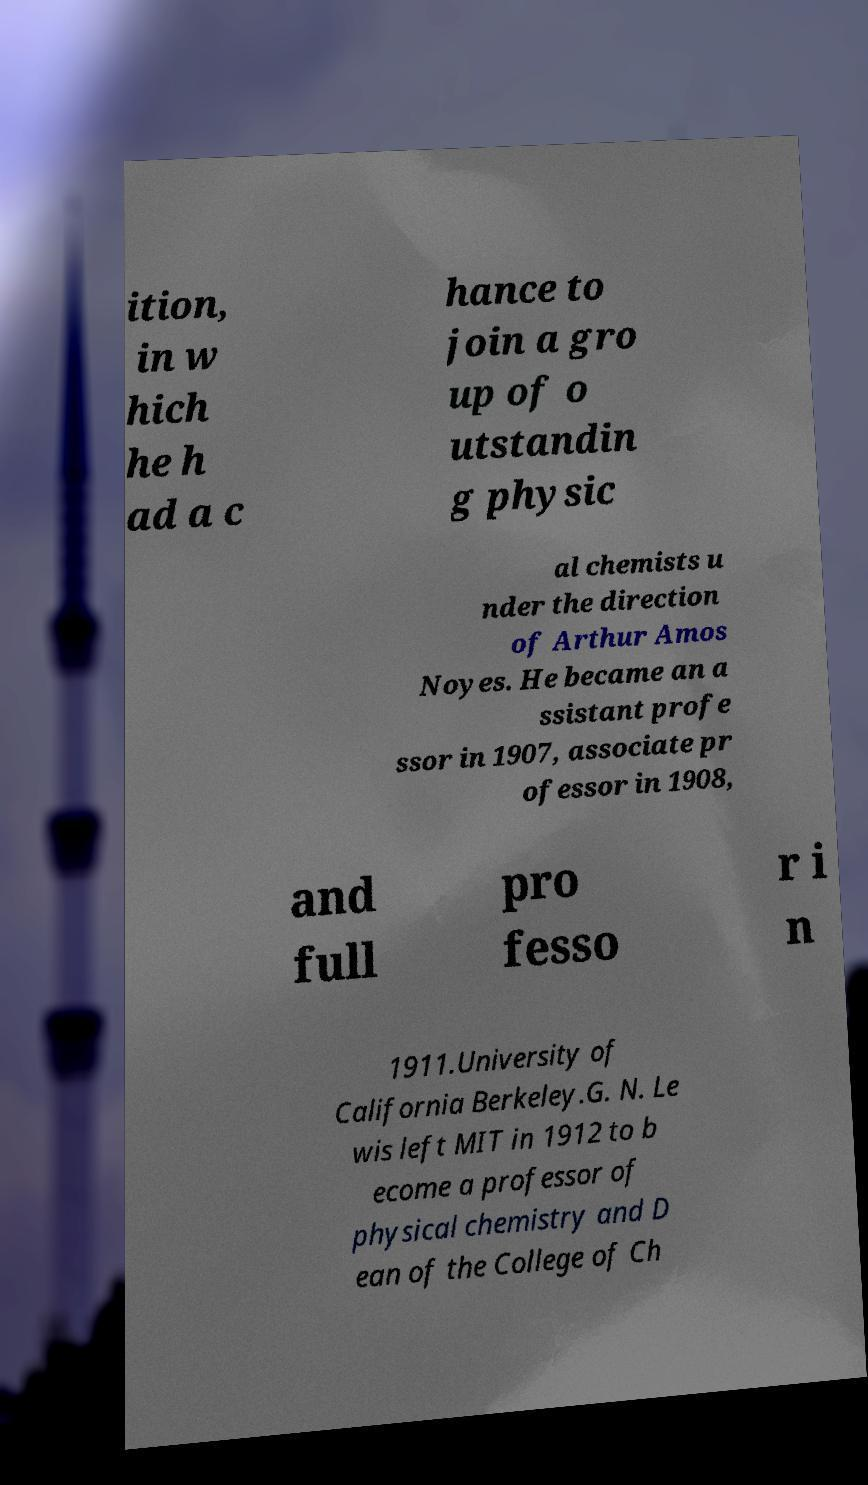Could you assist in decoding the text presented in this image and type it out clearly? ition, in w hich he h ad a c hance to join a gro up of o utstandin g physic al chemists u nder the direction of Arthur Amos Noyes. He became an a ssistant profe ssor in 1907, associate pr ofessor in 1908, and full pro fesso r i n 1911.University of California Berkeley.G. N. Le wis left MIT in 1912 to b ecome a professor of physical chemistry and D ean of the College of Ch 